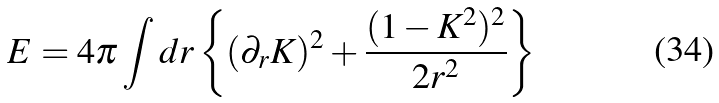<formula> <loc_0><loc_0><loc_500><loc_500>E = 4 \pi \int d r \left \{ ( \partial _ { r } K ) ^ { 2 } + \frac { ( 1 - K ^ { 2 } ) ^ { 2 } } { 2 r ^ { 2 } } \right \}</formula> 